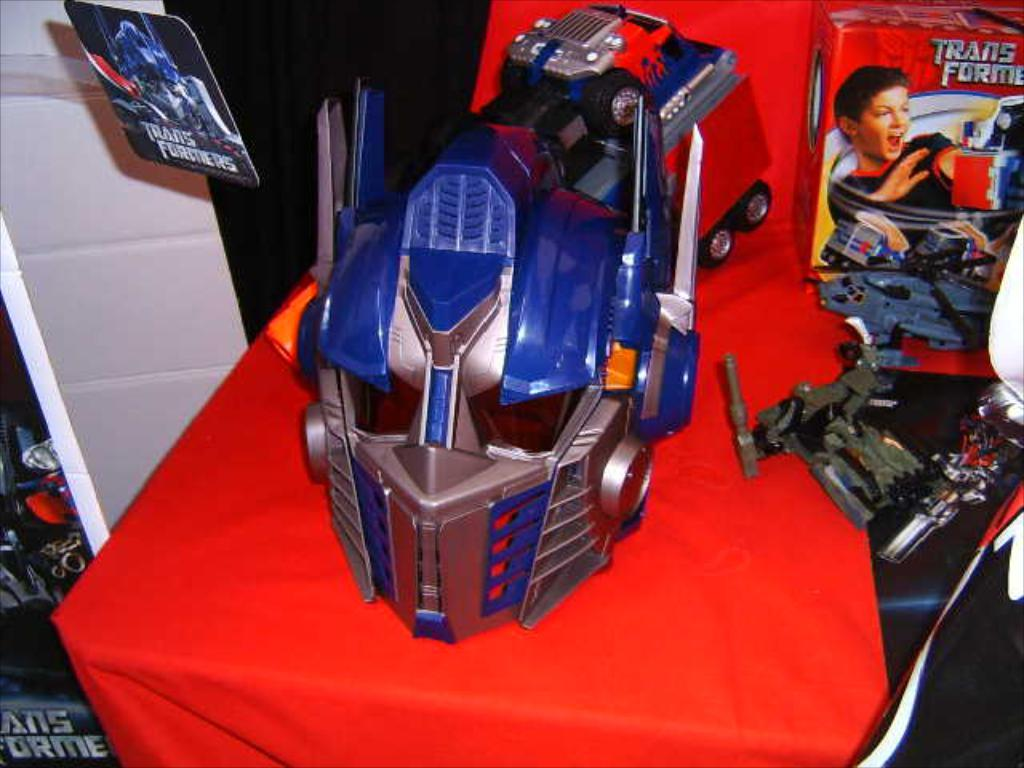Provide a one-sentence caption for the provided image. a TRANSFORMERS toy and box on display on a red cloth. 